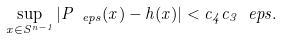<formula> <loc_0><loc_0><loc_500><loc_500>\sup _ { x \in S ^ { n - 1 } } \left | P _ { \ e p s } ( x ) - h ( x ) \right | < c _ { 4 } c _ { 3 } \ e p s .</formula> 